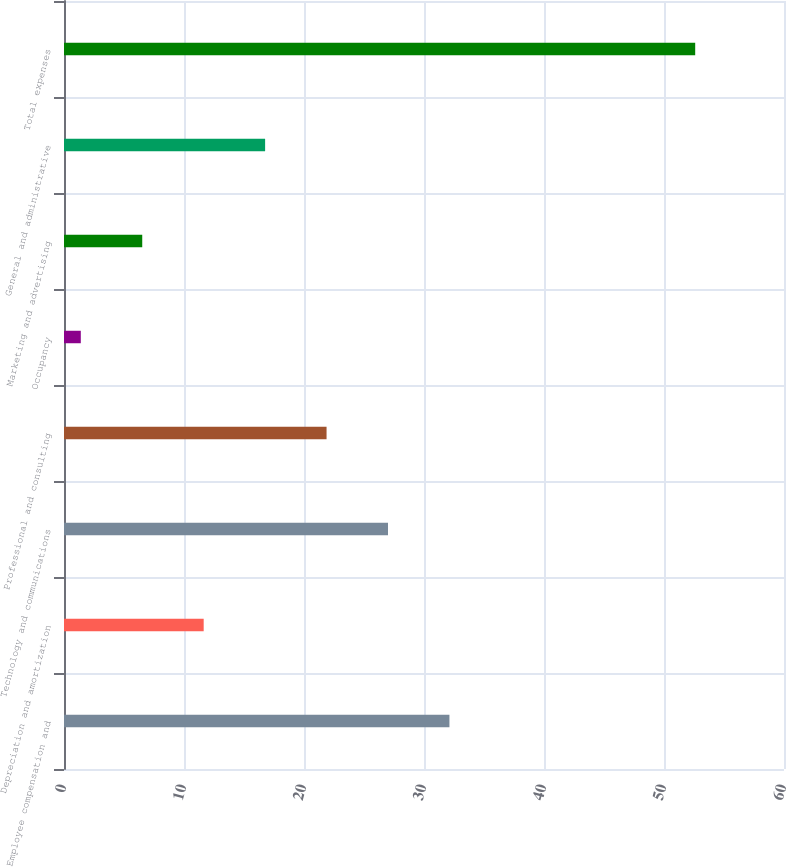<chart> <loc_0><loc_0><loc_500><loc_500><bar_chart><fcel>Employee compensation and<fcel>Depreciation and amortization<fcel>Technology and communications<fcel>Professional and consulting<fcel>Occupancy<fcel>Marketing and advertising<fcel>General and administrative<fcel>Total expenses<nl><fcel>32.12<fcel>11.64<fcel>27<fcel>21.88<fcel>1.4<fcel>6.52<fcel>16.76<fcel>52.6<nl></chart> 